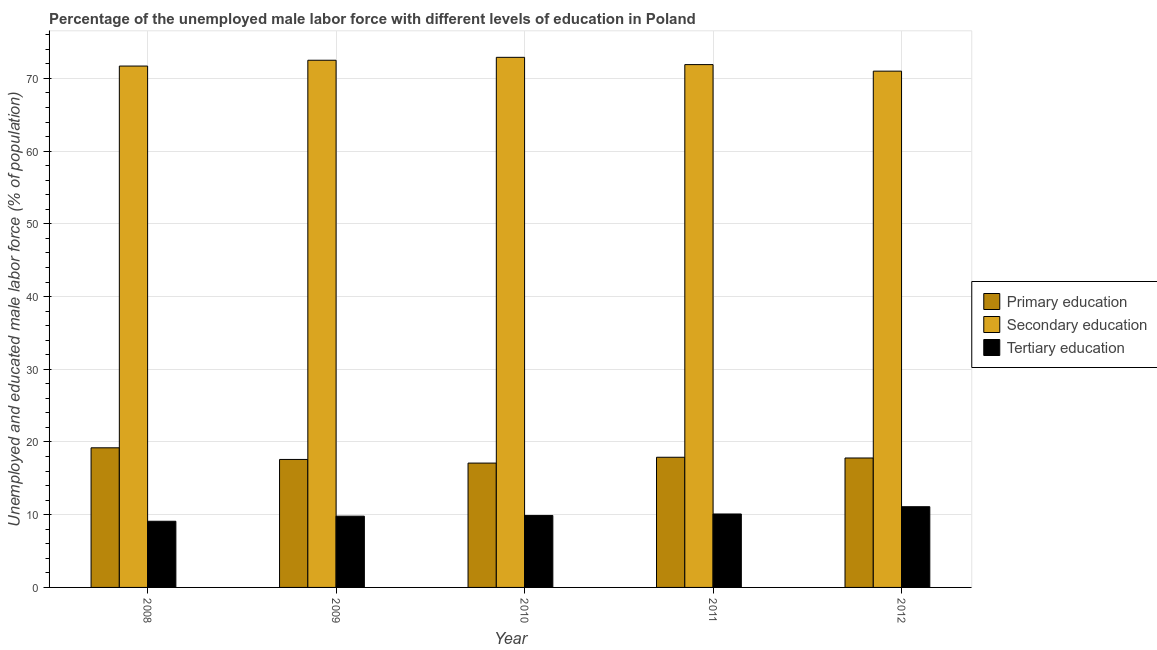How many different coloured bars are there?
Offer a very short reply. 3. Are the number of bars on each tick of the X-axis equal?
Your answer should be very brief. Yes. How many bars are there on the 2nd tick from the right?
Offer a terse response. 3. In how many cases, is the number of bars for a given year not equal to the number of legend labels?
Give a very brief answer. 0. What is the percentage of male labor force who received primary education in 2009?
Make the answer very short. 17.6. Across all years, what is the maximum percentage of male labor force who received primary education?
Ensure brevity in your answer.  19.2. Across all years, what is the minimum percentage of male labor force who received tertiary education?
Ensure brevity in your answer.  9.1. What is the total percentage of male labor force who received primary education in the graph?
Keep it short and to the point. 89.6. What is the difference between the percentage of male labor force who received secondary education in 2010 and that in 2012?
Give a very brief answer. 1.9. What is the difference between the percentage of male labor force who received tertiary education in 2008 and the percentage of male labor force who received primary education in 2012?
Give a very brief answer. -2. What is the average percentage of male labor force who received primary education per year?
Ensure brevity in your answer.  17.92. What is the ratio of the percentage of male labor force who received secondary education in 2009 to that in 2011?
Offer a terse response. 1.01. Is the percentage of male labor force who received tertiary education in 2010 less than that in 2011?
Your response must be concise. Yes. Is the difference between the percentage of male labor force who received primary education in 2009 and 2011 greater than the difference between the percentage of male labor force who received secondary education in 2009 and 2011?
Offer a terse response. No. What is the difference between the highest and the second highest percentage of male labor force who received secondary education?
Ensure brevity in your answer.  0.4. What is the difference between the highest and the lowest percentage of male labor force who received primary education?
Make the answer very short. 2.1. What does the 1st bar from the left in 2008 represents?
Provide a succinct answer. Primary education. What does the 2nd bar from the right in 2008 represents?
Ensure brevity in your answer.  Secondary education. How many bars are there?
Your answer should be very brief. 15. Are all the bars in the graph horizontal?
Make the answer very short. No. What is the difference between two consecutive major ticks on the Y-axis?
Ensure brevity in your answer.  10. Does the graph contain any zero values?
Offer a terse response. No. Does the graph contain grids?
Your answer should be very brief. Yes. Where does the legend appear in the graph?
Offer a very short reply. Center right. How many legend labels are there?
Provide a succinct answer. 3. What is the title of the graph?
Make the answer very short. Percentage of the unemployed male labor force with different levels of education in Poland. What is the label or title of the Y-axis?
Your answer should be very brief. Unemployed and educated male labor force (% of population). What is the Unemployed and educated male labor force (% of population) in Primary education in 2008?
Make the answer very short. 19.2. What is the Unemployed and educated male labor force (% of population) of Secondary education in 2008?
Provide a short and direct response. 71.7. What is the Unemployed and educated male labor force (% of population) in Tertiary education in 2008?
Your answer should be very brief. 9.1. What is the Unemployed and educated male labor force (% of population) in Primary education in 2009?
Your response must be concise. 17.6. What is the Unemployed and educated male labor force (% of population) in Secondary education in 2009?
Keep it short and to the point. 72.5. What is the Unemployed and educated male labor force (% of population) of Tertiary education in 2009?
Give a very brief answer. 9.8. What is the Unemployed and educated male labor force (% of population) of Primary education in 2010?
Offer a very short reply. 17.1. What is the Unemployed and educated male labor force (% of population) in Secondary education in 2010?
Give a very brief answer. 72.9. What is the Unemployed and educated male labor force (% of population) in Tertiary education in 2010?
Make the answer very short. 9.9. What is the Unemployed and educated male labor force (% of population) in Primary education in 2011?
Your answer should be compact. 17.9. What is the Unemployed and educated male labor force (% of population) of Secondary education in 2011?
Provide a short and direct response. 71.9. What is the Unemployed and educated male labor force (% of population) in Tertiary education in 2011?
Your answer should be very brief. 10.1. What is the Unemployed and educated male labor force (% of population) of Primary education in 2012?
Give a very brief answer. 17.8. What is the Unemployed and educated male labor force (% of population) of Secondary education in 2012?
Provide a short and direct response. 71. What is the Unemployed and educated male labor force (% of population) of Tertiary education in 2012?
Your response must be concise. 11.1. Across all years, what is the maximum Unemployed and educated male labor force (% of population) of Primary education?
Provide a short and direct response. 19.2. Across all years, what is the maximum Unemployed and educated male labor force (% of population) of Secondary education?
Make the answer very short. 72.9. Across all years, what is the maximum Unemployed and educated male labor force (% of population) in Tertiary education?
Provide a short and direct response. 11.1. Across all years, what is the minimum Unemployed and educated male labor force (% of population) in Primary education?
Provide a short and direct response. 17.1. Across all years, what is the minimum Unemployed and educated male labor force (% of population) of Secondary education?
Provide a short and direct response. 71. Across all years, what is the minimum Unemployed and educated male labor force (% of population) in Tertiary education?
Provide a short and direct response. 9.1. What is the total Unemployed and educated male labor force (% of population) of Primary education in the graph?
Keep it short and to the point. 89.6. What is the total Unemployed and educated male labor force (% of population) in Secondary education in the graph?
Your answer should be compact. 360. What is the difference between the Unemployed and educated male labor force (% of population) in Tertiary education in 2008 and that in 2009?
Ensure brevity in your answer.  -0.7. What is the difference between the Unemployed and educated male labor force (% of population) of Tertiary education in 2008 and that in 2011?
Your answer should be very brief. -1. What is the difference between the Unemployed and educated male labor force (% of population) of Secondary education in 2008 and that in 2012?
Ensure brevity in your answer.  0.7. What is the difference between the Unemployed and educated male labor force (% of population) of Tertiary education in 2008 and that in 2012?
Provide a short and direct response. -2. What is the difference between the Unemployed and educated male labor force (% of population) in Primary education in 2009 and that in 2010?
Provide a short and direct response. 0.5. What is the difference between the Unemployed and educated male labor force (% of population) of Secondary education in 2009 and that in 2010?
Keep it short and to the point. -0.4. What is the difference between the Unemployed and educated male labor force (% of population) in Tertiary education in 2009 and that in 2010?
Provide a succinct answer. -0.1. What is the difference between the Unemployed and educated male labor force (% of population) of Primary education in 2009 and that in 2011?
Your answer should be very brief. -0.3. What is the difference between the Unemployed and educated male labor force (% of population) in Primary education in 2009 and that in 2012?
Your response must be concise. -0.2. What is the difference between the Unemployed and educated male labor force (% of population) of Secondary education in 2009 and that in 2012?
Offer a very short reply. 1.5. What is the difference between the Unemployed and educated male labor force (% of population) of Tertiary education in 2009 and that in 2012?
Make the answer very short. -1.3. What is the difference between the Unemployed and educated male labor force (% of population) in Primary education in 2010 and that in 2011?
Give a very brief answer. -0.8. What is the difference between the Unemployed and educated male labor force (% of population) of Tertiary education in 2010 and that in 2011?
Your response must be concise. -0.2. What is the difference between the Unemployed and educated male labor force (% of population) of Primary education in 2010 and that in 2012?
Your response must be concise. -0.7. What is the difference between the Unemployed and educated male labor force (% of population) in Primary education in 2011 and that in 2012?
Give a very brief answer. 0.1. What is the difference between the Unemployed and educated male labor force (% of population) of Secondary education in 2011 and that in 2012?
Keep it short and to the point. 0.9. What is the difference between the Unemployed and educated male labor force (% of population) in Primary education in 2008 and the Unemployed and educated male labor force (% of population) in Secondary education in 2009?
Make the answer very short. -53.3. What is the difference between the Unemployed and educated male labor force (% of population) in Primary education in 2008 and the Unemployed and educated male labor force (% of population) in Tertiary education in 2009?
Your response must be concise. 9.4. What is the difference between the Unemployed and educated male labor force (% of population) of Secondary education in 2008 and the Unemployed and educated male labor force (% of population) of Tertiary education in 2009?
Provide a succinct answer. 61.9. What is the difference between the Unemployed and educated male labor force (% of population) of Primary education in 2008 and the Unemployed and educated male labor force (% of population) of Secondary education in 2010?
Your response must be concise. -53.7. What is the difference between the Unemployed and educated male labor force (% of population) of Primary education in 2008 and the Unemployed and educated male labor force (% of population) of Tertiary education in 2010?
Make the answer very short. 9.3. What is the difference between the Unemployed and educated male labor force (% of population) in Secondary education in 2008 and the Unemployed and educated male labor force (% of population) in Tertiary education in 2010?
Provide a succinct answer. 61.8. What is the difference between the Unemployed and educated male labor force (% of population) of Primary education in 2008 and the Unemployed and educated male labor force (% of population) of Secondary education in 2011?
Your response must be concise. -52.7. What is the difference between the Unemployed and educated male labor force (% of population) in Secondary education in 2008 and the Unemployed and educated male labor force (% of population) in Tertiary education in 2011?
Provide a short and direct response. 61.6. What is the difference between the Unemployed and educated male labor force (% of population) of Primary education in 2008 and the Unemployed and educated male labor force (% of population) of Secondary education in 2012?
Make the answer very short. -51.8. What is the difference between the Unemployed and educated male labor force (% of population) in Secondary education in 2008 and the Unemployed and educated male labor force (% of population) in Tertiary education in 2012?
Your response must be concise. 60.6. What is the difference between the Unemployed and educated male labor force (% of population) in Primary education in 2009 and the Unemployed and educated male labor force (% of population) in Secondary education in 2010?
Your response must be concise. -55.3. What is the difference between the Unemployed and educated male labor force (% of population) of Primary education in 2009 and the Unemployed and educated male labor force (% of population) of Tertiary education in 2010?
Keep it short and to the point. 7.7. What is the difference between the Unemployed and educated male labor force (% of population) in Secondary education in 2009 and the Unemployed and educated male labor force (% of population) in Tertiary education in 2010?
Give a very brief answer. 62.6. What is the difference between the Unemployed and educated male labor force (% of population) of Primary education in 2009 and the Unemployed and educated male labor force (% of population) of Secondary education in 2011?
Provide a short and direct response. -54.3. What is the difference between the Unemployed and educated male labor force (% of population) of Primary education in 2009 and the Unemployed and educated male labor force (% of population) of Tertiary education in 2011?
Provide a short and direct response. 7.5. What is the difference between the Unemployed and educated male labor force (% of population) in Secondary education in 2009 and the Unemployed and educated male labor force (% of population) in Tertiary education in 2011?
Give a very brief answer. 62.4. What is the difference between the Unemployed and educated male labor force (% of population) of Primary education in 2009 and the Unemployed and educated male labor force (% of population) of Secondary education in 2012?
Keep it short and to the point. -53.4. What is the difference between the Unemployed and educated male labor force (% of population) in Primary education in 2009 and the Unemployed and educated male labor force (% of population) in Tertiary education in 2012?
Make the answer very short. 6.5. What is the difference between the Unemployed and educated male labor force (% of population) of Secondary education in 2009 and the Unemployed and educated male labor force (% of population) of Tertiary education in 2012?
Provide a succinct answer. 61.4. What is the difference between the Unemployed and educated male labor force (% of population) of Primary education in 2010 and the Unemployed and educated male labor force (% of population) of Secondary education in 2011?
Ensure brevity in your answer.  -54.8. What is the difference between the Unemployed and educated male labor force (% of population) in Secondary education in 2010 and the Unemployed and educated male labor force (% of population) in Tertiary education in 2011?
Make the answer very short. 62.8. What is the difference between the Unemployed and educated male labor force (% of population) in Primary education in 2010 and the Unemployed and educated male labor force (% of population) in Secondary education in 2012?
Provide a succinct answer. -53.9. What is the difference between the Unemployed and educated male labor force (% of population) in Primary education in 2010 and the Unemployed and educated male labor force (% of population) in Tertiary education in 2012?
Your answer should be compact. 6. What is the difference between the Unemployed and educated male labor force (% of population) of Secondary education in 2010 and the Unemployed and educated male labor force (% of population) of Tertiary education in 2012?
Your response must be concise. 61.8. What is the difference between the Unemployed and educated male labor force (% of population) of Primary education in 2011 and the Unemployed and educated male labor force (% of population) of Secondary education in 2012?
Make the answer very short. -53.1. What is the difference between the Unemployed and educated male labor force (% of population) in Primary education in 2011 and the Unemployed and educated male labor force (% of population) in Tertiary education in 2012?
Offer a terse response. 6.8. What is the difference between the Unemployed and educated male labor force (% of population) of Secondary education in 2011 and the Unemployed and educated male labor force (% of population) of Tertiary education in 2012?
Keep it short and to the point. 60.8. What is the average Unemployed and educated male labor force (% of population) in Primary education per year?
Offer a very short reply. 17.92. What is the average Unemployed and educated male labor force (% of population) of Secondary education per year?
Provide a succinct answer. 72. In the year 2008, what is the difference between the Unemployed and educated male labor force (% of population) of Primary education and Unemployed and educated male labor force (% of population) of Secondary education?
Make the answer very short. -52.5. In the year 2008, what is the difference between the Unemployed and educated male labor force (% of population) of Primary education and Unemployed and educated male labor force (% of population) of Tertiary education?
Your answer should be very brief. 10.1. In the year 2008, what is the difference between the Unemployed and educated male labor force (% of population) in Secondary education and Unemployed and educated male labor force (% of population) in Tertiary education?
Your answer should be compact. 62.6. In the year 2009, what is the difference between the Unemployed and educated male labor force (% of population) of Primary education and Unemployed and educated male labor force (% of population) of Secondary education?
Provide a short and direct response. -54.9. In the year 2009, what is the difference between the Unemployed and educated male labor force (% of population) in Secondary education and Unemployed and educated male labor force (% of population) in Tertiary education?
Offer a very short reply. 62.7. In the year 2010, what is the difference between the Unemployed and educated male labor force (% of population) in Primary education and Unemployed and educated male labor force (% of population) in Secondary education?
Provide a succinct answer. -55.8. In the year 2010, what is the difference between the Unemployed and educated male labor force (% of population) in Primary education and Unemployed and educated male labor force (% of population) in Tertiary education?
Your response must be concise. 7.2. In the year 2010, what is the difference between the Unemployed and educated male labor force (% of population) in Secondary education and Unemployed and educated male labor force (% of population) in Tertiary education?
Provide a succinct answer. 63. In the year 2011, what is the difference between the Unemployed and educated male labor force (% of population) in Primary education and Unemployed and educated male labor force (% of population) in Secondary education?
Make the answer very short. -54. In the year 2011, what is the difference between the Unemployed and educated male labor force (% of population) of Secondary education and Unemployed and educated male labor force (% of population) of Tertiary education?
Ensure brevity in your answer.  61.8. In the year 2012, what is the difference between the Unemployed and educated male labor force (% of population) in Primary education and Unemployed and educated male labor force (% of population) in Secondary education?
Make the answer very short. -53.2. In the year 2012, what is the difference between the Unemployed and educated male labor force (% of population) of Primary education and Unemployed and educated male labor force (% of population) of Tertiary education?
Keep it short and to the point. 6.7. In the year 2012, what is the difference between the Unemployed and educated male labor force (% of population) in Secondary education and Unemployed and educated male labor force (% of population) in Tertiary education?
Provide a short and direct response. 59.9. What is the ratio of the Unemployed and educated male labor force (% of population) in Secondary education in 2008 to that in 2009?
Give a very brief answer. 0.99. What is the ratio of the Unemployed and educated male labor force (% of population) of Primary education in 2008 to that in 2010?
Offer a very short reply. 1.12. What is the ratio of the Unemployed and educated male labor force (% of population) in Secondary education in 2008 to that in 2010?
Your response must be concise. 0.98. What is the ratio of the Unemployed and educated male labor force (% of population) in Tertiary education in 2008 to that in 2010?
Ensure brevity in your answer.  0.92. What is the ratio of the Unemployed and educated male labor force (% of population) of Primary education in 2008 to that in 2011?
Provide a short and direct response. 1.07. What is the ratio of the Unemployed and educated male labor force (% of population) of Secondary education in 2008 to that in 2011?
Your answer should be compact. 1. What is the ratio of the Unemployed and educated male labor force (% of population) in Tertiary education in 2008 to that in 2011?
Offer a very short reply. 0.9. What is the ratio of the Unemployed and educated male labor force (% of population) of Primary education in 2008 to that in 2012?
Provide a succinct answer. 1.08. What is the ratio of the Unemployed and educated male labor force (% of population) in Secondary education in 2008 to that in 2012?
Keep it short and to the point. 1.01. What is the ratio of the Unemployed and educated male labor force (% of population) of Tertiary education in 2008 to that in 2012?
Give a very brief answer. 0.82. What is the ratio of the Unemployed and educated male labor force (% of population) in Primary education in 2009 to that in 2010?
Make the answer very short. 1.03. What is the ratio of the Unemployed and educated male labor force (% of population) in Secondary education in 2009 to that in 2010?
Ensure brevity in your answer.  0.99. What is the ratio of the Unemployed and educated male labor force (% of population) in Primary education in 2009 to that in 2011?
Give a very brief answer. 0.98. What is the ratio of the Unemployed and educated male labor force (% of population) of Secondary education in 2009 to that in 2011?
Your answer should be compact. 1.01. What is the ratio of the Unemployed and educated male labor force (% of population) of Tertiary education in 2009 to that in 2011?
Keep it short and to the point. 0.97. What is the ratio of the Unemployed and educated male labor force (% of population) in Secondary education in 2009 to that in 2012?
Give a very brief answer. 1.02. What is the ratio of the Unemployed and educated male labor force (% of population) in Tertiary education in 2009 to that in 2012?
Make the answer very short. 0.88. What is the ratio of the Unemployed and educated male labor force (% of population) in Primary education in 2010 to that in 2011?
Keep it short and to the point. 0.96. What is the ratio of the Unemployed and educated male labor force (% of population) in Secondary education in 2010 to that in 2011?
Ensure brevity in your answer.  1.01. What is the ratio of the Unemployed and educated male labor force (% of population) in Tertiary education in 2010 to that in 2011?
Keep it short and to the point. 0.98. What is the ratio of the Unemployed and educated male labor force (% of population) in Primary education in 2010 to that in 2012?
Provide a succinct answer. 0.96. What is the ratio of the Unemployed and educated male labor force (% of population) of Secondary education in 2010 to that in 2012?
Provide a succinct answer. 1.03. What is the ratio of the Unemployed and educated male labor force (% of population) of Tertiary education in 2010 to that in 2012?
Your answer should be compact. 0.89. What is the ratio of the Unemployed and educated male labor force (% of population) in Primary education in 2011 to that in 2012?
Provide a short and direct response. 1.01. What is the ratio of the Unemployed and educated male labor force (% of population) of Secondary education in 2011 to that in 2012?
Ensure brevity in your answer.  1.01. What is the ratio of the Unemployed and educated male labor force (% of population) of Tertiary education in 2011 to that in 2012?
Provide a succinct answer. 0.91. What is the difference between the highest and the second highest Unemployed and educated male labor force (% of population) of Primary education?
Your response must be concise. 1.3. What is the difference between the highest and the second highest Unemployed and educated male labor force (% of population) of Secondary education?
Give a very brief answer. 0.4. What is the difference between the highest and the second highest Unemployed and educated male labor force (% of population) in Tertiary education?
Your answer should be very brief. 1. What is the difference between the highest and the lowest Unemployed and educated male labor force (% of population) of Secondary education?
Offer a very short reply. 1.9. What is the difference between the highest and the lowest Unemployed and educated male labor force (% of population) of Tertiary education?
Your response must be concise. 2. 